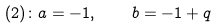<formula> <loc_0><loc_0><loc_500><loc_500>( 2 ) \colon a = - 1 , \quad b = - 1 + q</formula> 